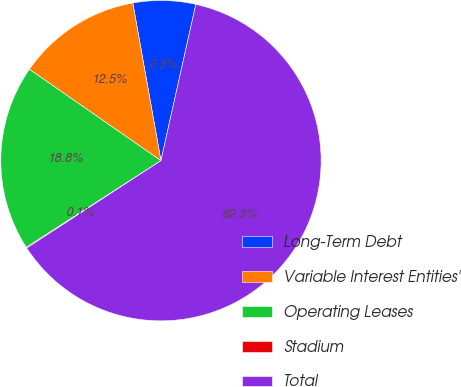<chart> <loc_0><loc_0><loc_500><loc_500><pie_chart><fcel>Long-Term Debt<fcel>Variable Interest Entities'<fcel>Operating Leases<fcel>Stadium<fcel>Total<nl><fcel>6.31%<fcel>12.53%<fcel>18.76%<fcel>0.09%<fcel>62.32%<nl></chart> 